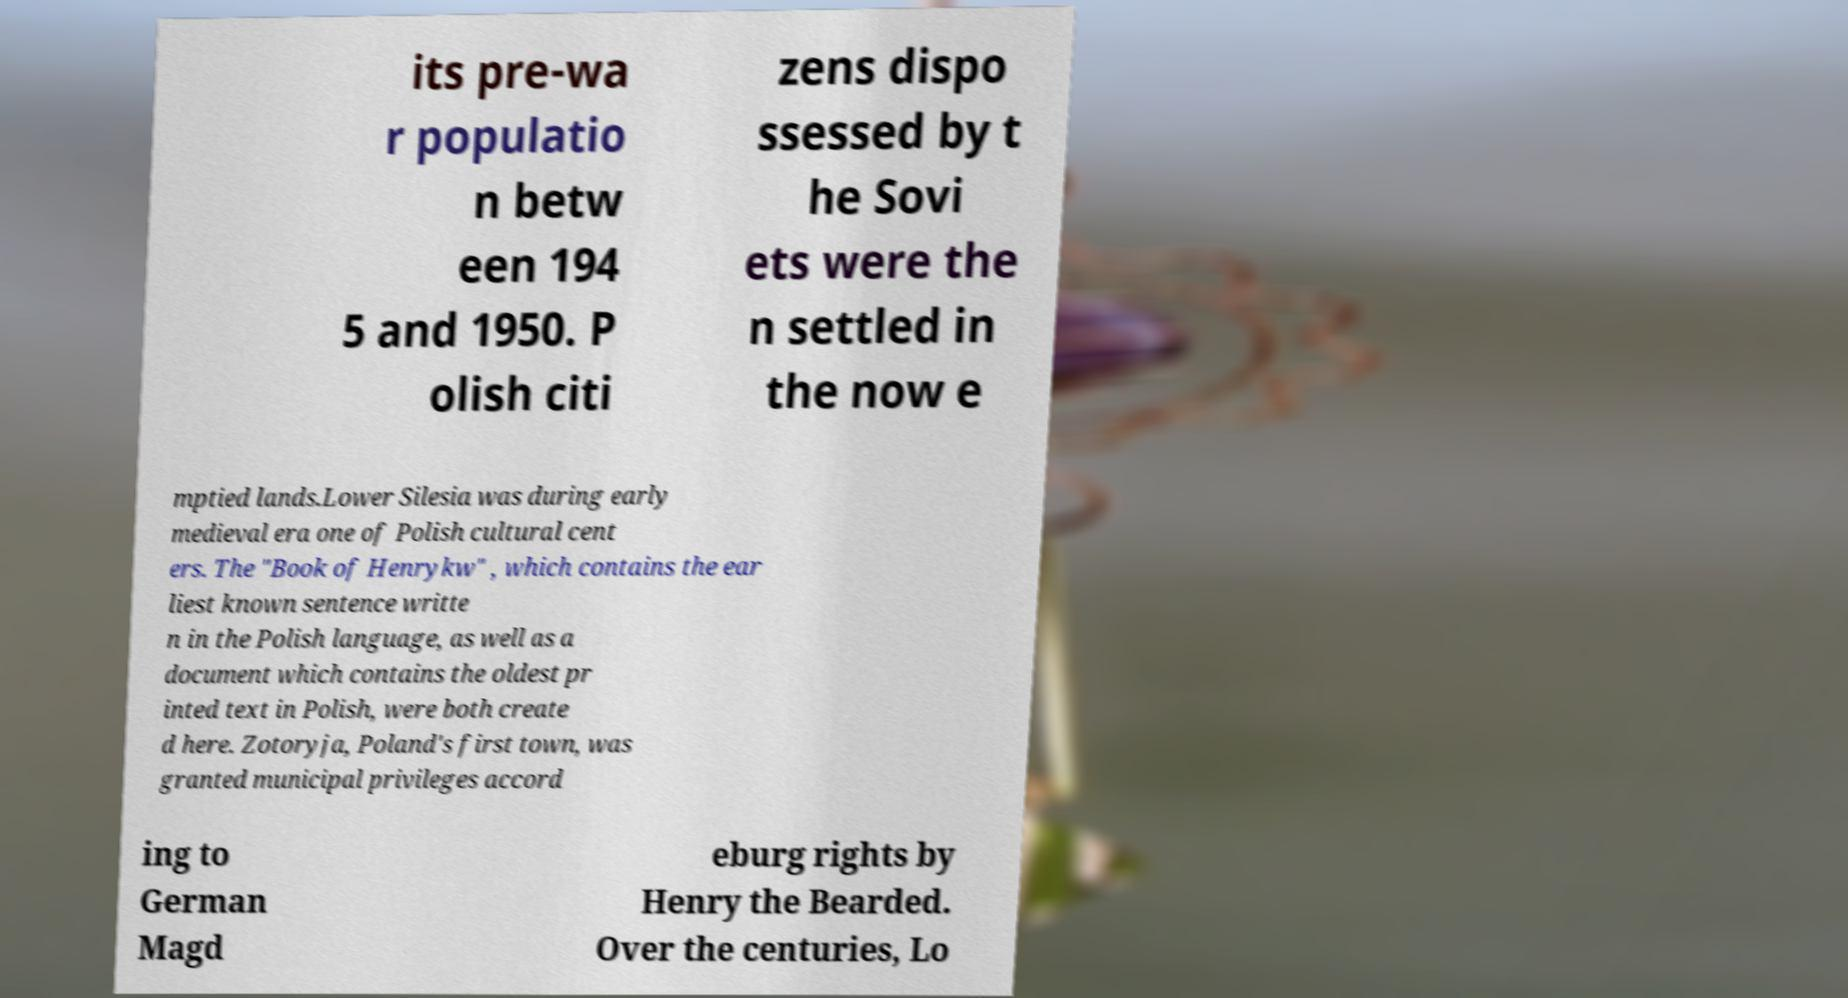I need the written content from this picture converted into text. Can you do that? its pre-wa r populatio n betw een 194 5 and 1950. P olish citi zens dispo ssessed by t he Sovi ets were the n settled in the now e mptied lands.Lower Silesia was during early medieval era one of Polish cultural cent ers. The "Book of Henrykw" , which contains the ear liest known sentence writte n in the Polish language, as well as a document which contains the oldest pr inted text in Polish, were both create d here. Zotoryja, Poland's first town, was granted municipal privileges accord ing to German Magd eburg rights by Henry the Bearded. Over the centuries, Lo 